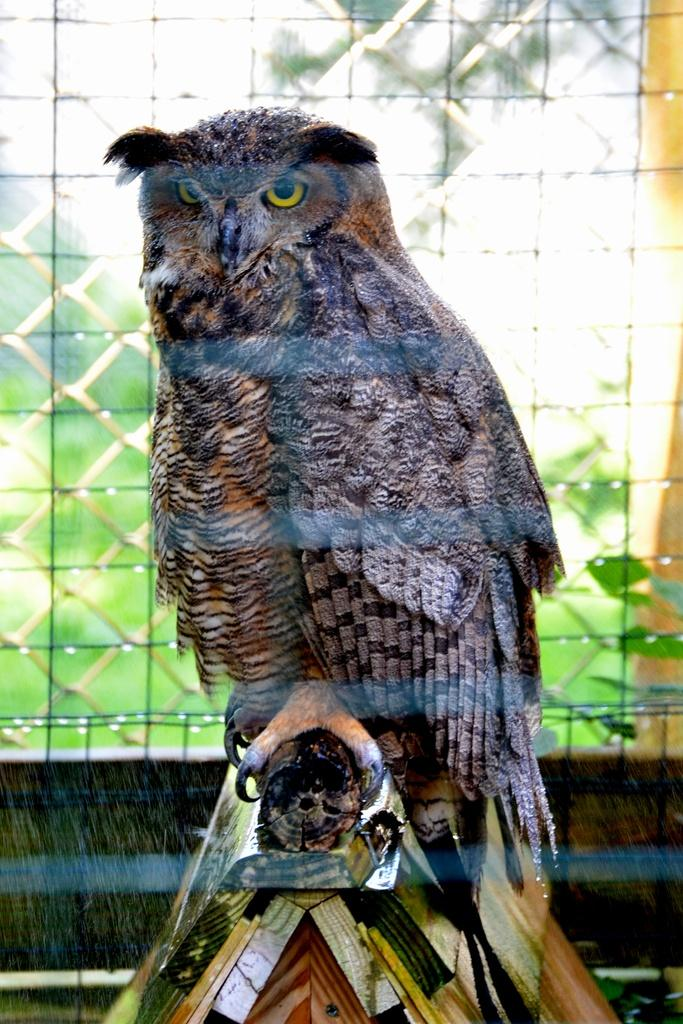What animal can be seen in the picture? There is an owl in the picture. What type of architectural feature is present in the background of the picture? There is a grill window in the background of the picture. What type of vegetation is visible in the background of the picture? Green leaves are visible in the background of the picture. What color crayon is being used to draw on the protest sign in the image? There is no protest sign or crayon present in the image; it features an owl and a grill window in the background. 